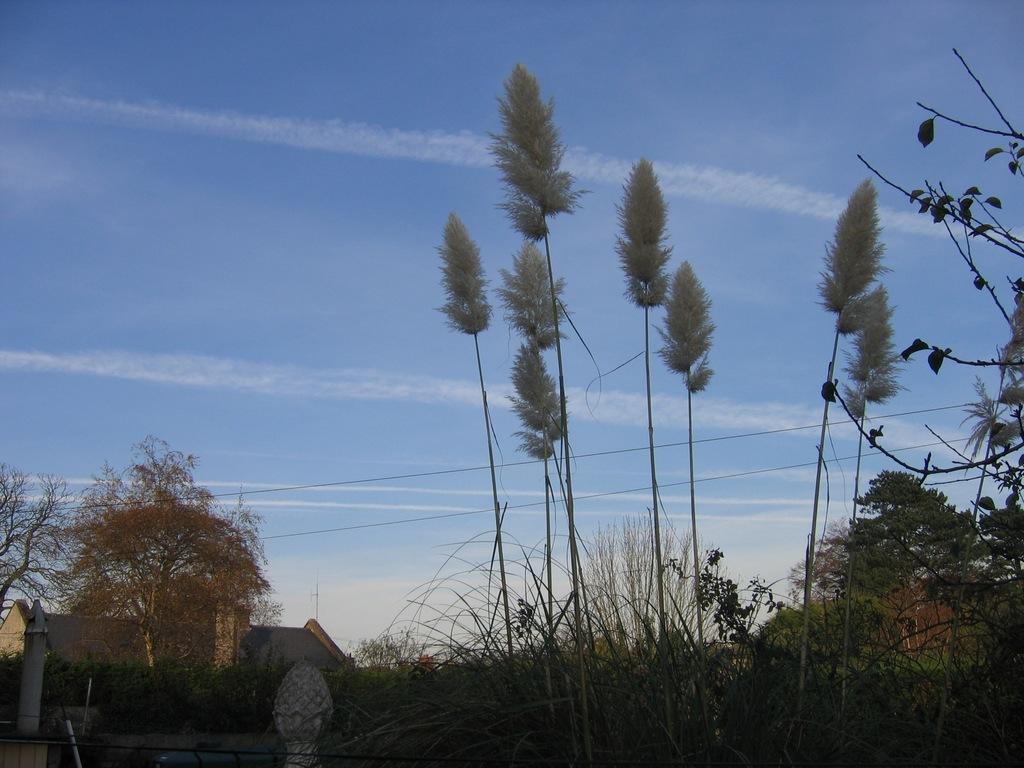Describe this image in one or two sentences. In this picture I can observe some plants and trees. On the left side it is looking like a house. In the background I can observe sky. 